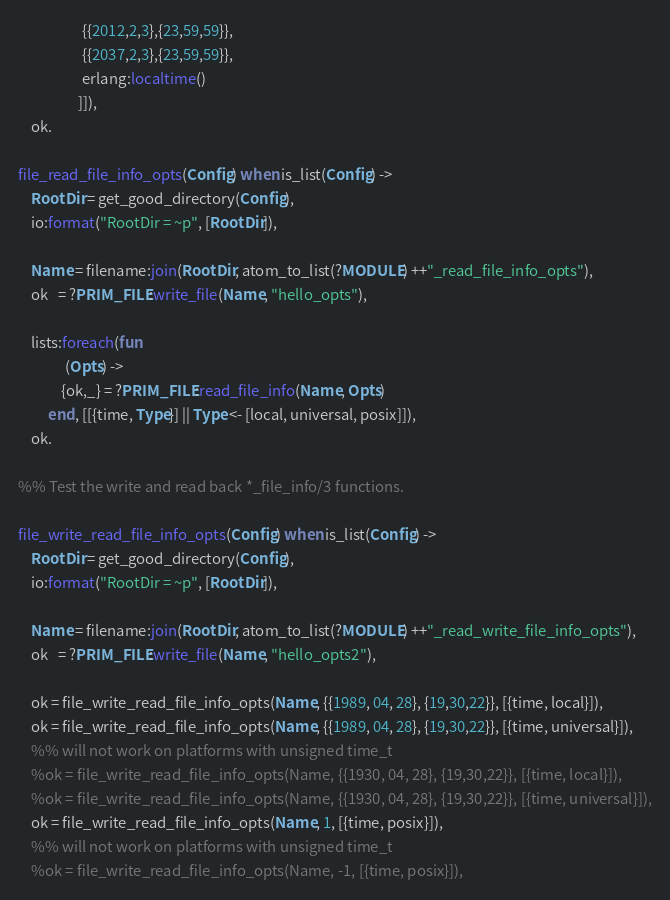<code> <loc_0><loc_0><loc_500><loc_500><_Erlang_>				   {{2012,2,3},{23,59,59}},
				   {{2037,2,3},{23,59,59}},
				   erlang:localtime()
				  ]]),
    ok.

file_read_file_info_opts(Config) when is_list(Config) ->
    RootDir = get_good_directory(Config),
    io:format("RootDir = ~p", [RootDir]),

    Name = filename:join(RootDir, atom_to_list(?MODULE) ++"_read_file_info_opts"),
    ok   = ?PRIM_FILE:write_file(Name, "hello_opts"),

    lists:foreach(fun
		      (Opts) ->
			 {ok,_} = ?PRIM_FILE:read_file_info(Name, Opts)
		 end, [[{time, Type}] || Type <- [local, universal, posix]]),
    ok.

%% Test the write and read back *_file_info/3 functions.

file_write_read_file_info_opts(Config) when is_list(Config) ->
    RootDir = get_good_directory(Config),
    io:format("RootDir = ~p", [RootDir]),

    Name = filename:join(RootDir, atom_to_list(?MODULE) ++"_read_write_file_info_opts"),
    ok   = ?PRIM_FILE:write_file(Name, "hello_opts2"),

    ok = file_write_read_file_info_opts(Name, {{1989, 04, 28}, {19,30,22}}, [{time, local}]),
    ok = file_write_read_file_info_opts(Name, {{1989, 04, 28}, {19,30,22}}, [{time, universal}]),
    %% will not work on platforms with unsigned time_t
    %ok = file_write_read_file_info_opts(Name, {{1930, 04, 28}, {19,30,22}}, [{time, local}]),
    %ok = file_write_read_file_info_opts(Name, {{1930, 04, 28}, {19,30,22}}, [{time, universal}]),
    ok = file_write_read_file_info_opts(Name, 1, [{time, posix}]),
    %% will not work on platforms with unsigned time_t
    %ok = file_write_read_file_info_opts(Name, -1, [{time, posix}]),</code> 